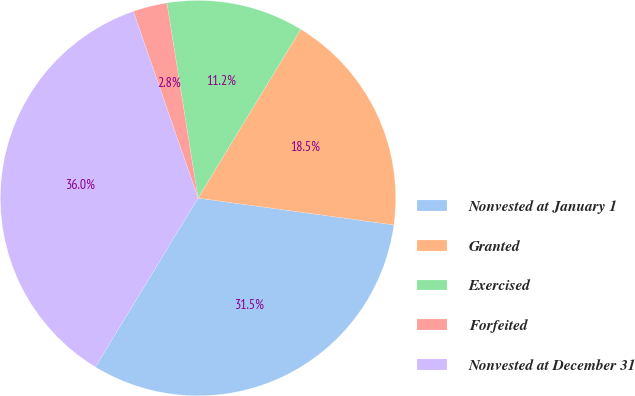Convert chart. <chart><loc_0><loc_0><loc_500><loc_500><pie_chart><fcel>Nonvested at January 1<fcel>Granted<fcel>Exercised<fcel>Forfeited<fcel>Nonvested at December 31<nl><fcel>31.53%<fcel>18.47%<fcel>11.21%<fcel>2.79%<fcel>35.99%<nl></chart> 